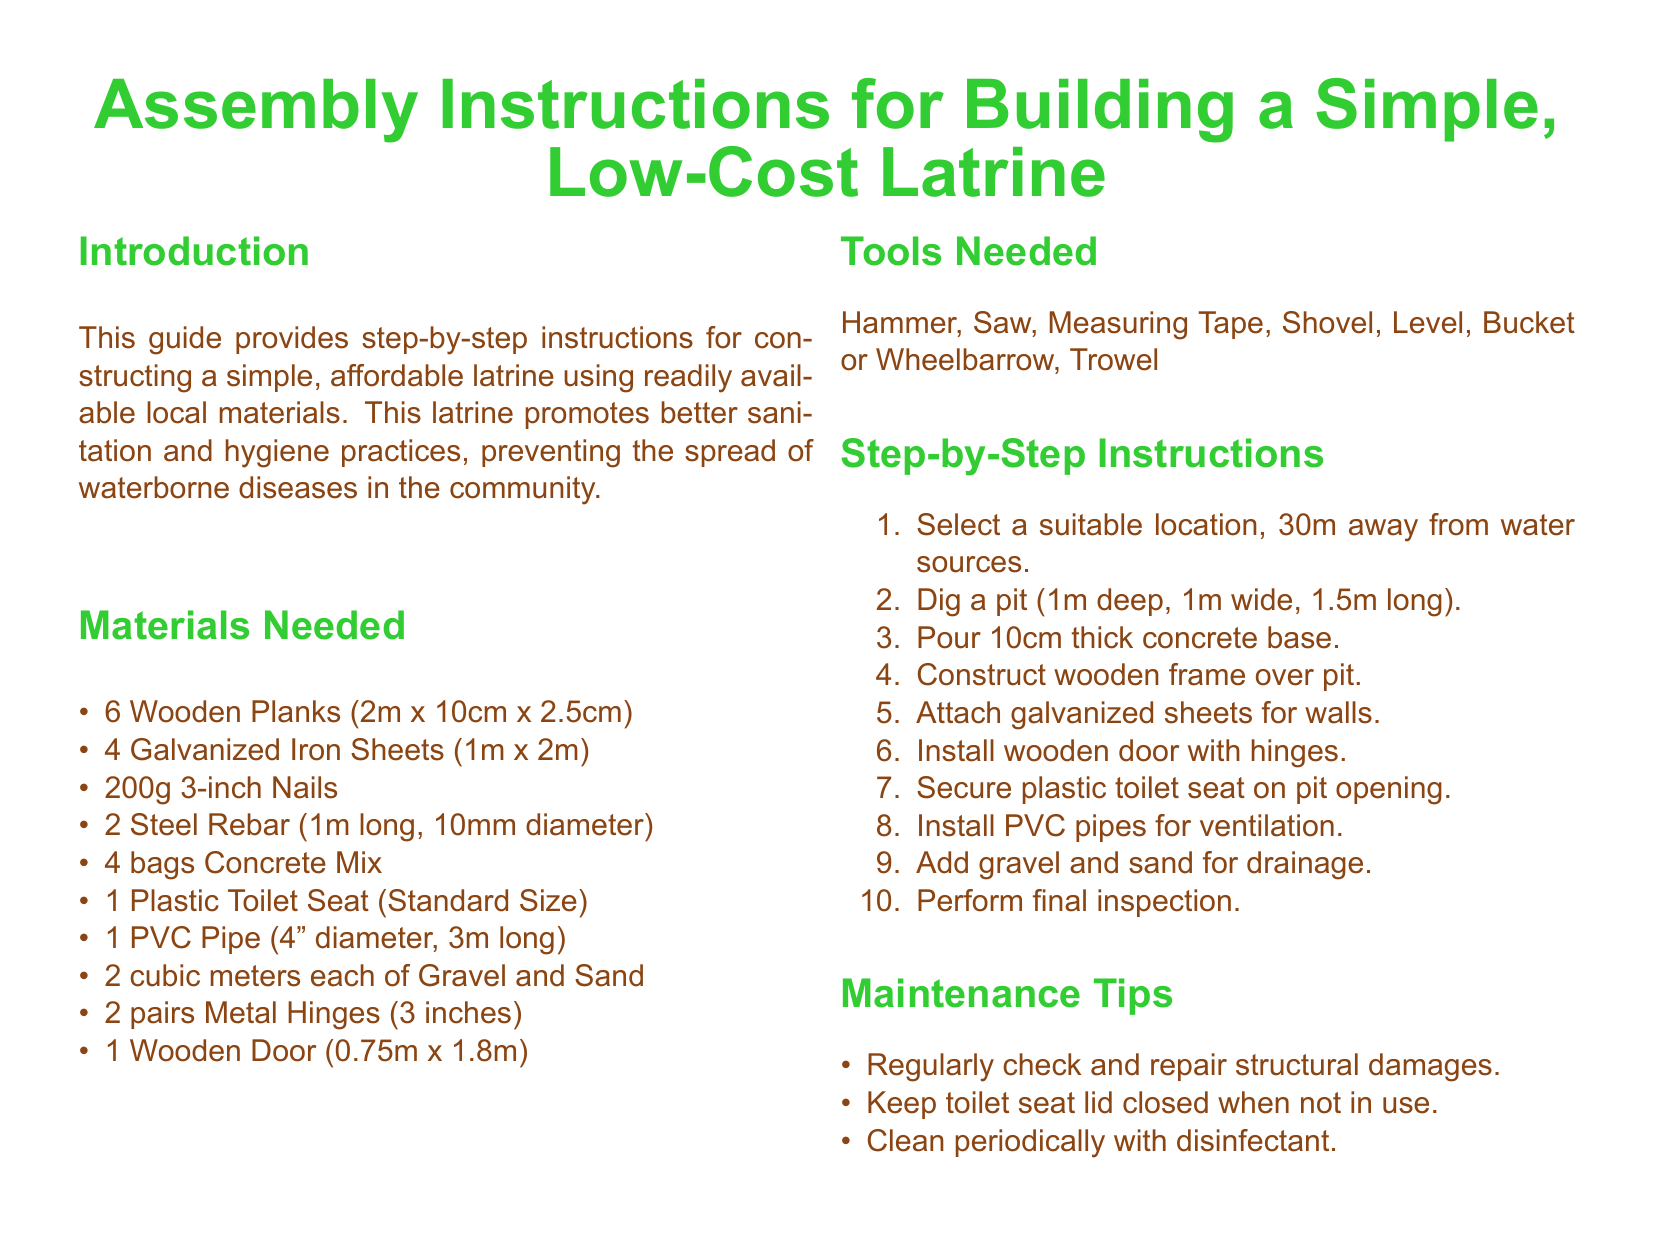What is the size of the wooden planks? The size of the wooden planks mentioned in the document is 2m x 10cm x 2.5cm.
Answer: 2m x 10cm x 2.5cm How many galvanized iron sheets are required? The document lists that 4 galvanized iron sheets are needed for construction.
Answer: 4 What is the diameter of the PVC pipe? The document specifies that the PVC pipe has a diameter of 4 inches.
Answer: 4 inches What is the depth of the pit to be dug? The document states that the pit should be 1m deep.
Answer: 1m How thick should the concrete base be? The instructions mention that the concrete base should be 10cm thick.
Answer: 10cm What materials are needed for drainage? The document indicates that 2 cubic meters each of gravel and sand are needed for drainage.
Answer: Gravel and Sand How many pairs of metal hinges are required? According to the document, 2 pairs of metal hinges are needed.
Answer: 2 pairs What is the standard size of the toilet seat? The document specifies a standard size for the plastic toilet seat.
Answer: Standard Size What should be checked regularly for maintenance? The maintenance tips advise regularly checking and repairing structural damages.
Answer: Structural damages 